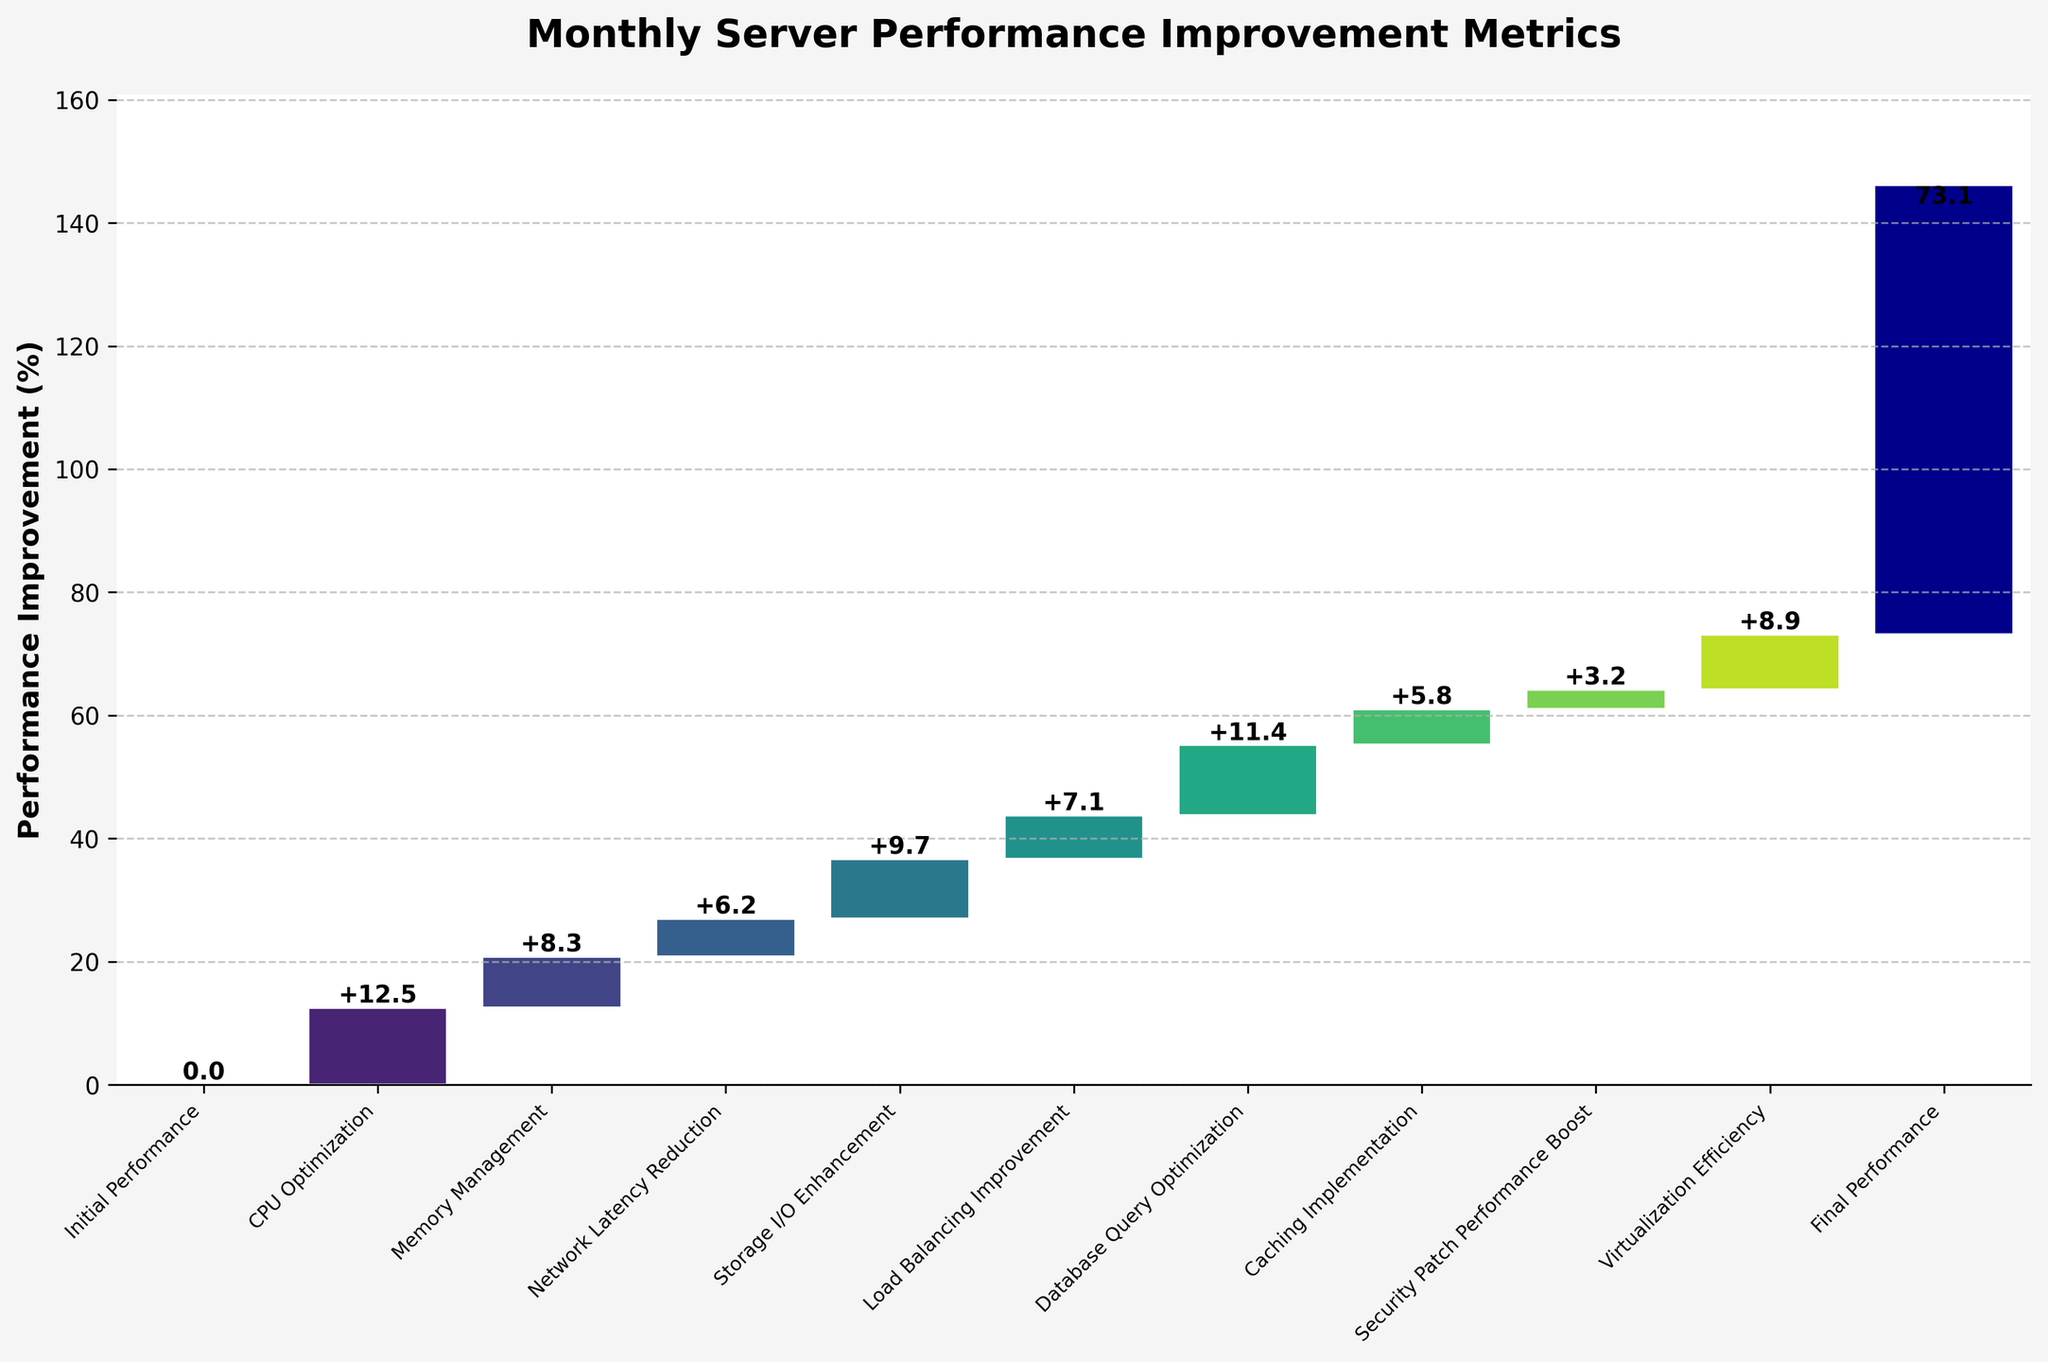What is the title of the chart? The title of a chart is usually displayed prominently at the top of the figure. In this case, it shows "Monthly Server Performance Improvement Metrics".
Answer: Monthly Server Performance Improvement Metrics How many categories are displayed in the chart? Count the number of distinct bars or data points labeled along the x-axis to determine the number of categories.
Answer: 11 Which category had the highest performance improvement value? Identify the bar with the maximum height (excluding the initial and final performance), which represents the highest value. Database Query Optimization has the highest value of 11.4.
Answer: Database Query Optimization What is the total performance improvement percentage from all enhancements? Sum all the individual improvement values from the categories excluding the initial performance. The sum is 12.5 + 8.3 + 6.2 + 9.7 + 7.1 + 11.4 + 5.8 + 3.2 + 8.9 = 73.1%, matching the final performance number.
Answer: 73.1% By how much did the CPU Optimization improve the initial performance? Look at the value labeled next to the bar for the CPU Optimization category. It is 12.5.
Answer: 12.5 Which category shows the lowest improvement and what is its value? Identify the bar with the smallest height (excluding the initial and final performance) and read off the value next to it. Security Patch Performance Boost shows the lowest value of 3.2.
Answer: Security Patch Performance Boost, 3.2 How much is the performance difference between Memory Management and Caching Implementation? Subtract the value for Caching Implementation from the value for Memory Management: 8.3 - 5.8 = 2.5.
Answer: 2.5 What cumulative performance improvement is represented by the bar for Database Query Optimization? The cumulative performance increase up to and including Database Query Optimization is the sum of all previous improvements: 12.5 + 8.3 + 6.2 + 9.7 + 7.1 + 11.4, which totals to 55.2.
Answer: 55.2 Which two categories combined improve performance more than CPU Optimization alone? Combine pairs of values and compare to the CPU Optimization value 12.5. Memory Management (8.3) + Network Latency Reduction (6.2) = 14.5, which is more than 12.5.
Answer: Memory Management and Network Latency Reduction 